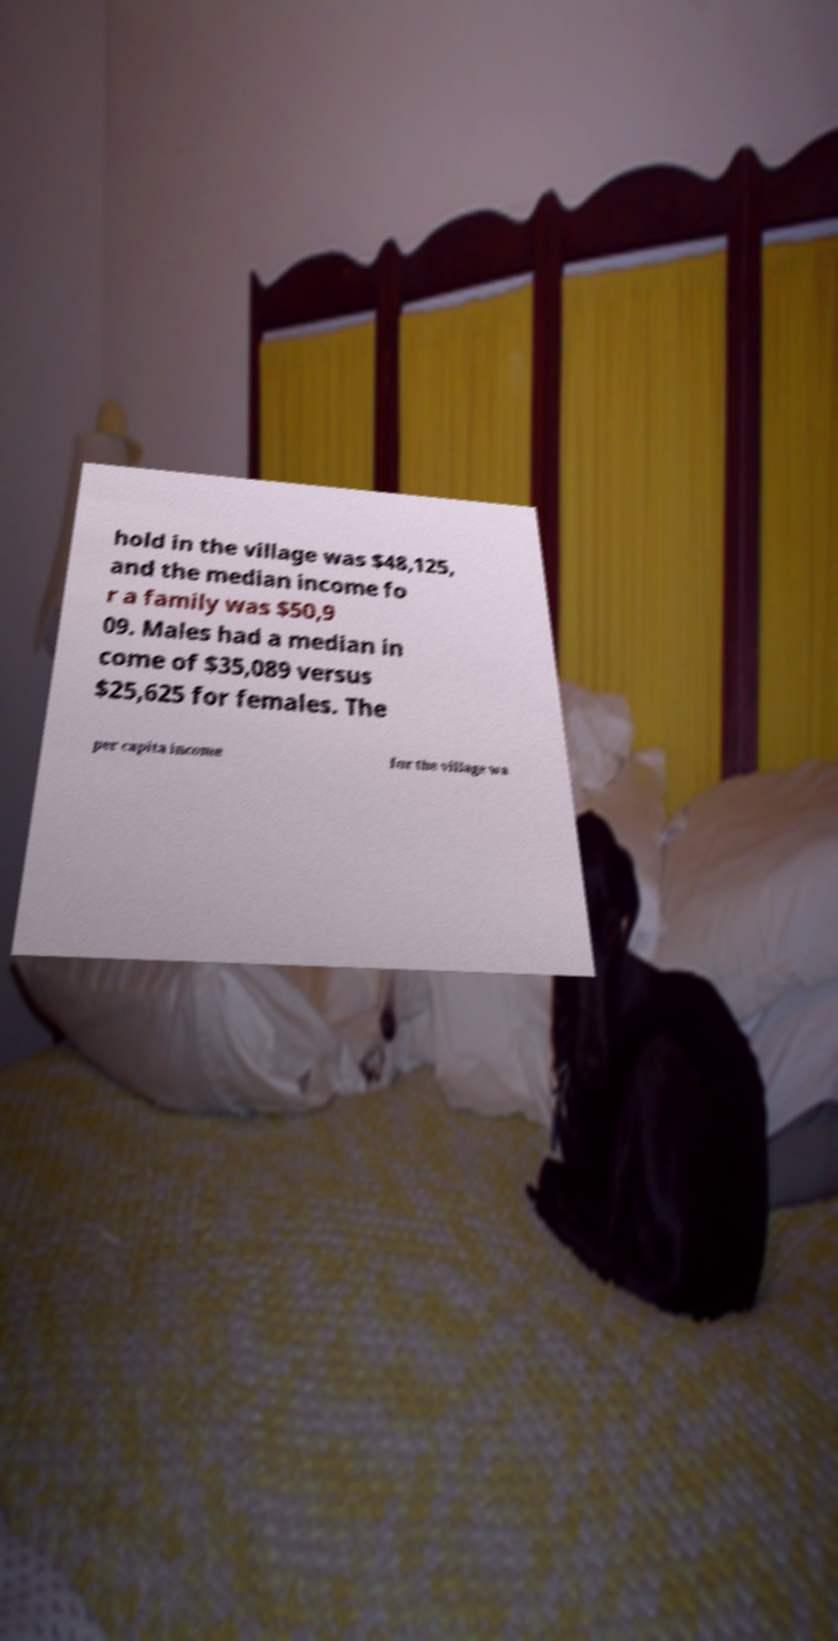Can you read and provide the text displayed in the image?This photo seems to have some interesting text. Can you extract and type it out for me? hold in the village was $48,125, and the median income fo r a family was $50,9 09. Males had a median in come of $35,089 versus $25,625 for females. The per capita income for the village wa 